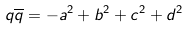<formula> <loc_0><loc_0><loc_500><loc_500>q \overline { q } = - a ^ { 2 } + b ^ { 2 } + c ^ { 2 } + d ^ { 2 }</formula> 